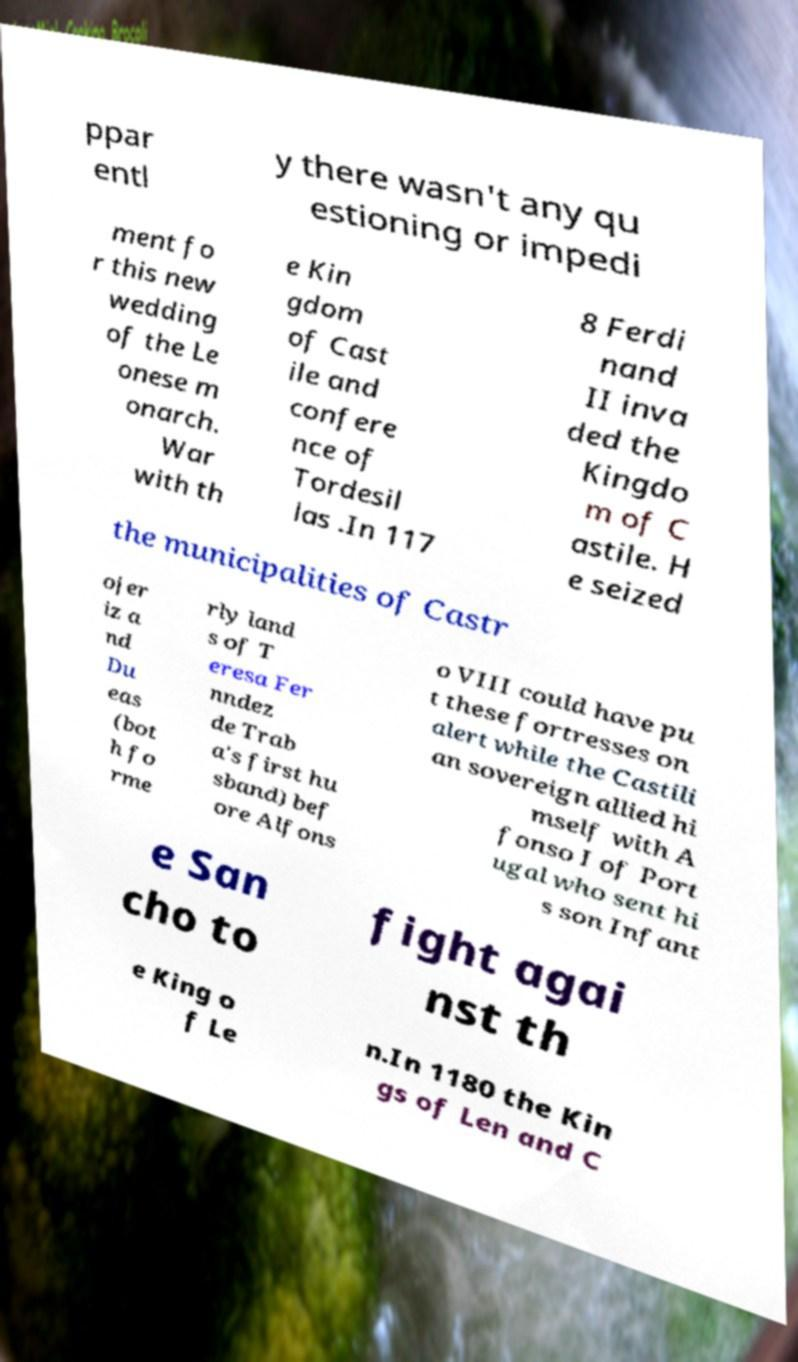For documentation purposes, I need the text within this image transcribed. Could you provide that? ppar entl y there wasn't any qu estioning or impedi ment fo r this new wedding of the Le onese m onarch. War with th e Kin gdom of Cast ile and confere nce of Tordesil las .In 117 8 Ferdi nand II inva ded the Kingdo m of C astile. H e seized the municipalities of Castr ojer iz a nd Du eas (bot h fo rme rly land s of T eresa Fer nndez de Trab a's first hu sband) bef ore Alfons o VIII could have pu t these fortresses on alert while the Castili an sovereign allied hi mself with A fonso I of Port ugal who sent hi s son Infant e San cho to fight agai nst th e King o f Le n.In 1180 the Kin gs of Len and C 